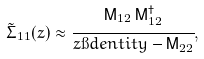<formula> <loc_0><loc_0><loc_500><loc_500>\tilde { \Sigma } _ { 1 1 } ( z ) \approx \cfrac { \mathsf M _ { 1 2 } \, \mathsf M _ { 1 2 } ^ { \dagger } } { z \i d e n t i t y - \mathsf M _ { 2 2 } } ,</formula> 